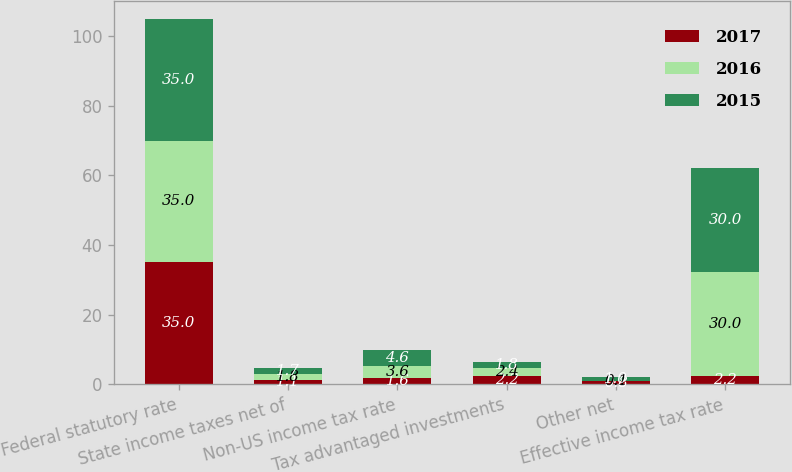Convert chart to OTSL. <chart><loc_0><loc_0><loc_500><loc_500><stacked_bar_chart><ecel><fcel>Federal statutory rate<fcel>State income taxes net of<fcel>Non-US income tax rate<fcel>Tax advantaged investments<fcel>Other net<fcel>Effective income tax rate<nl><fcel>2017<fcel>35<fcel>1.1<fcel>1.6<fcel>2.2<fcel>0.8<fcel>2.2<nl><fcel>2016<fcel>35<fcel>1.8<fcel>3.6<fcel>2.4<fcel>0.1<fcel>30<nl><fcel>2015<fcel>35<fcel>1.7<fcel>4.6<fcel>1.8<fcel>1<fcel>30<nl></chart> 